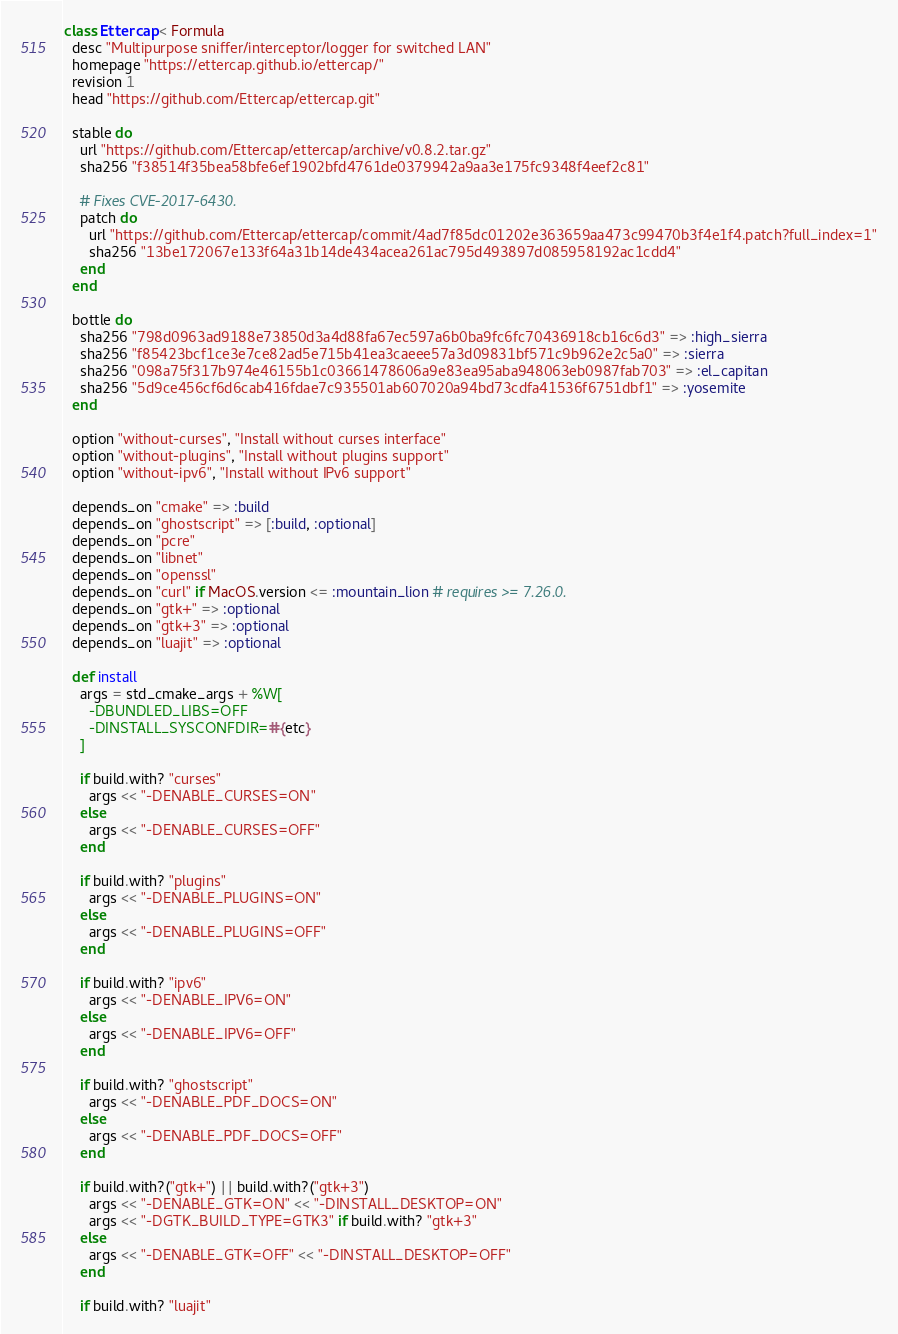<code> <loc_0><loc_0><loc_500><loc_500><_Ruby_>class Ettercap < Formula
  desc "Multipurpose sniffer/interceptor/logger for switched LAN"
  homepage "https://ettercap.github.io/ettercap/"
  revision 1
  head "https://github.com/Ettercap/ettercap.git"

  stable do
    url "https://github.com/Ettercap/ettercap/archive/v0.8.2.tar.gz"
    sha256 "f38514f35bea58bfe6ef1902bfd4761de0379942a9aa3e175fc9348f4eef2c81"

    # Fixes CVE-2017-6430.
    patch do
      url "https://github.com/Ettercap/ettercap/commit/4ad7f85dc01202e363659aa473c99470b3f4e1f4.patch?full_index=1"
      sha256 "13be172067e133f64a31b14de434acea261ac795d493897d085958192ac1cdd4"
    end
  end

  bottle do
    sha256 "798d0963ad9188e73850d3a4d88fa67ec597a6b0ba9fc6fc70436918cb16c6d3" => :high_sierra
    sha256 "f85423bcf1ce3e7ce82ad5e715b41ea3caeee57a3d09831bf571c9b962e2c5a0" => :sierra
    sha256 "098a75f317b974e46155b1c03661478606a9e83ea95aba948063eb0987fab703" => :el_capitan
    sha256 "5d9ce456cf6d6cab416fdae7c935501ab607020a94bd73cdfa41536f6751dbf1" => :yosemite
  end

  option "without-curses", "Install without curses interface"
  option "without-plugins", "Install without plugins support"
  option "without-ipv6", "Install without IPv6 support"

  depends_on "cmake" => :build
  depends_on "ghostscript" => [:build, :optional]
  depends_on "pcre"
  depends_on "libnet"
  depends_on "openssl"
  depends_on "curl" if MacOS.version <= :mountain_lion # requires >= 7.26.0.
  depends_on "gtk+" => :optional
  depends_on "gtk+3" => :optional
  depends_on "luajit" => :optional

  def install
    args = std_cmake_args + %W[
      -DBUNDLED_LIBS=OFF
      -DINSTALL_SYSCONFDIR=#{etc}
    ]

    if build.with? "curses"
      args << "-DENABLE_CURSES=ON"
    else
      args << "-DENABLE_CURSES=OFF"
    end

    if build.with? "plugins"
      args << "-DENABLE_PLUGINS=ON"
    else
      args << "-DENABLE_PLUGINS=OFF"
    end

    if build.with? "ipv6"
      args << "-DENABLE_IPV6=ON"
    else
      args << "-DENABLE_IPV6=OFF"
    end

    if build.with? "ghostscript"
      args << "-DENABLE_PDF_DOCS=ON"
    else
      args << "-DENABLE_PDF_DOCS=OFF"
    end

    if build.with?("gtk+") || build.with?("gtk+3")
      args << "-DENABLE_GTK=ON" << "-DINSTALL_DESKTOP=ON"
      args << "-DGTK_BUILD_TYPE=GTK3" if build.with? "gtk+3"
    else
      args << "-DENABLE_GTK=OFF" << "-DINSTALL_DESKTOP=OFF"
    end

    if build.with? "luajit"</code> 